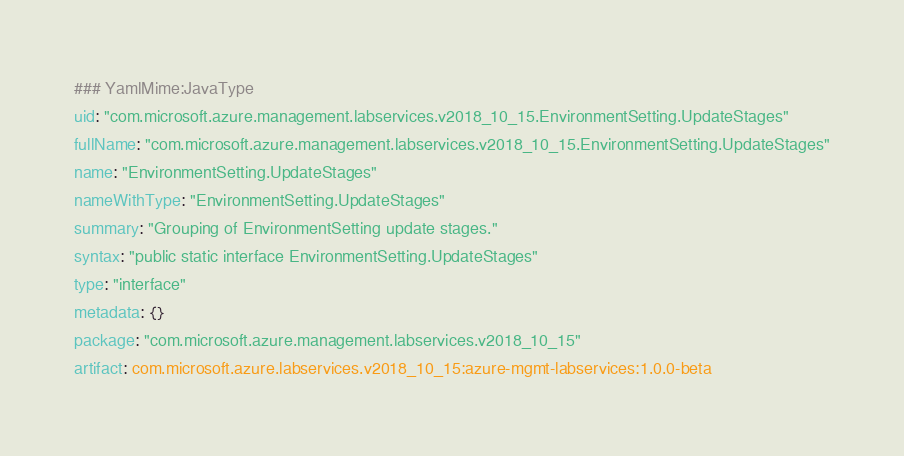<code> <loc_0><loc_0><loc_500><loc_500><_YAML_>### YamlMime:JavaType
uid: "com.microsoft.azure.management.labservices.v2018_10_15.EnvironmentSetting.UpdateStages"
fullName: "com.microsoft.azure.management.labservices.v2018_10_15.EnvironmentSetting.UpdateStages"
name: "EnvironmentSetting.UpdateStages"
nameWithType: "EnvironmentSetting.UpdateStages"
summary: "Grouping of EnvironmentSetting update stages."
syntax: "public static interface EnvironmentSetting.UpdateStages"
type: "interface"
metadata: {}
package: "com.microsoft.azure.management.labservices.v2018_10_15"
artifact: com.microsoft.azure.labservices.v2018_10_15:azure-mgmt-labservices:1.0.0-beta
</code> 